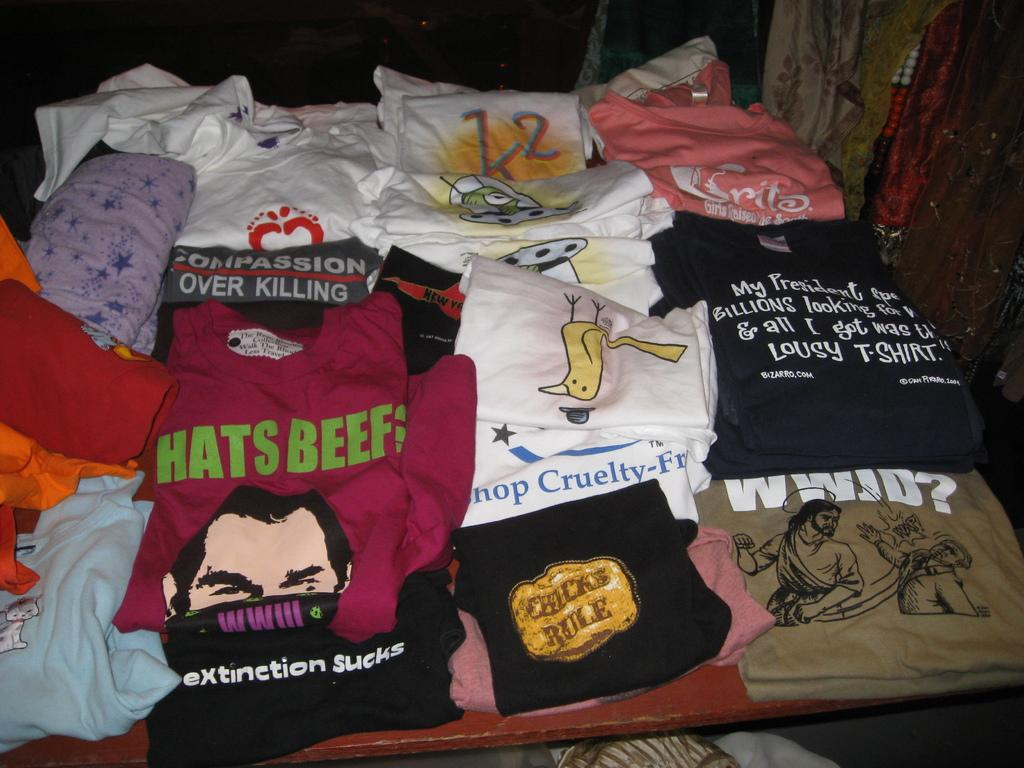What type of clothing items are in the image? There are T-shirts in the image. Can you describe the colors of the T-shirts? The T-shirts are in different colors. On what object are the T-shirts placed? The T-shirts are placed on an object. What type of fruit is placed on top of the T-shirts in the image? There is no fruit present in the image; only T-shirts in different colors are visible. 